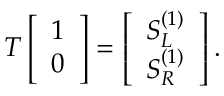<formula> <loc_0><loc_0><loc_500><loc_500>T \left [ \begin{array} { l } { 1 } \\ { 0 } \end{array} \right ] = \left [ \begin{array} { l } { S _ { L } ^ { ( 1 ) } } \\ { S _ { R } ^ { ( 1 ) } } \end{array} \right ] .</formula> 